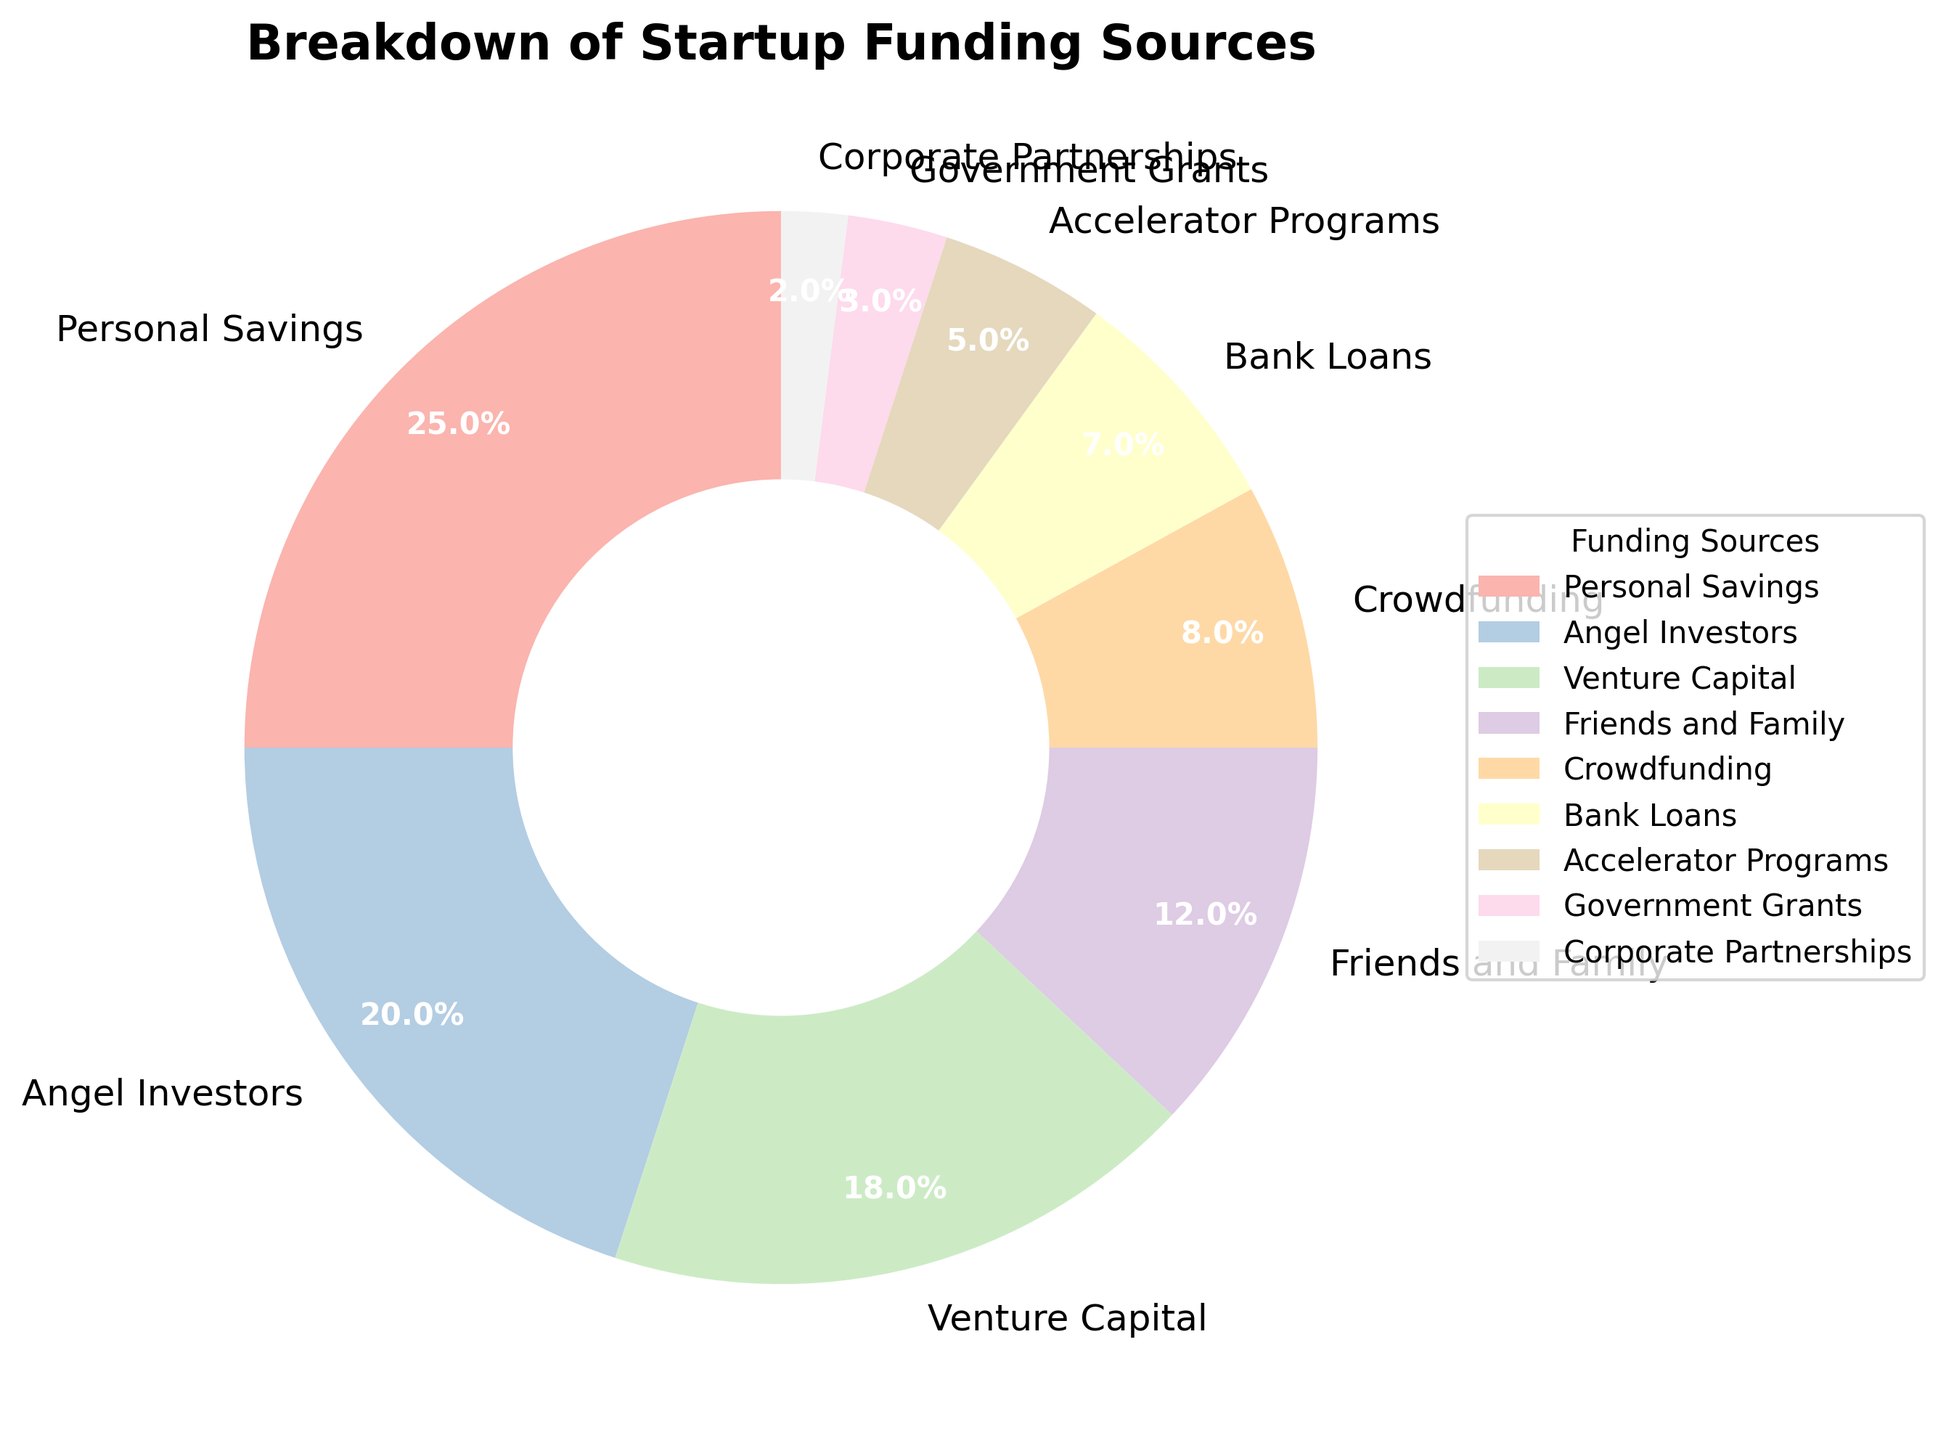Which funding source has the largest percentage? According to the pie chart, the largest segment corresponds to Personal Savings.
Answer: Personal Savings What is the combined percentage of funding from Friends and Family and Bank Loans? The pie chart shows Friends and Family at 12% and Bank Loans at 7%. Sum these percentages: 12% + 7% = 19%.
Answer: 19% How do the percentages for Angel Investors and Government Grants compare? Angel Investors contribute 20% of the funding, while Government Grants account for 3%. 20% is greater than 3%.
Answer: Angel Investors > Government Grants What percentage of funding comes from sources other than Personal Savings and Angel Investors? First, sum the percentages for Personal Savings and Angel Investors: 25% + 20% = 45%. The total percentage is 100%, so the percentage from other sources is 100% - 45% = 55%.
Answer: 55% What is the difference in funding percentage between Venture Capital and Crowdfunding? The pie chart shows Venture Capital at 18% and Crowdfunding at 8%. The difference is 18% - 8% = 10%.
Answer: 10% Among the funding sources, which three contribute the smallest percentages and what are their combined total? The three smallest segments in the pie chart are Corporate Partnerships (2%), Government Grants (3%), and Accelerator Programs (5%). The combined total is 2% + 3% + 5% = 10%.
Answer: 10% Which funding sources together make up exactly half of the total funding? Looking at the pie chart, Personal Savings (25%) and Angel Investors (20%) together make up: 25% + 20% = 45%. Including Friends and Family adds an additional 12%, totaling: 45% + 12% = 57%, which is more than half. Hence, the sources that total up to exactly half (or less, combined to get exactly half here) without going over would be Personal Savings (25%), Angel Investors (20%), and Crowdfunding (8%) which gives: 25% + 20% + 8% = 53%, which is less than 50%. Hence, Personal Savings and Angel Investors make up close ~50%.
Answer: Personal Savings and Angel Investors Does Bank Loans make up less than 10% of the total funding? According to the pie chart, Bank Loans account for 7%, which is indeed less than 10%.
Answer: Yes What is the visual style of the wedges in the pie chart? The wedges are displayed using pastel colors, with white bolded text for the percentages inside each wedge. The labels are placed outwardly with a legend on the side for further clarity.
Answer: Pastel colors with white bold text 